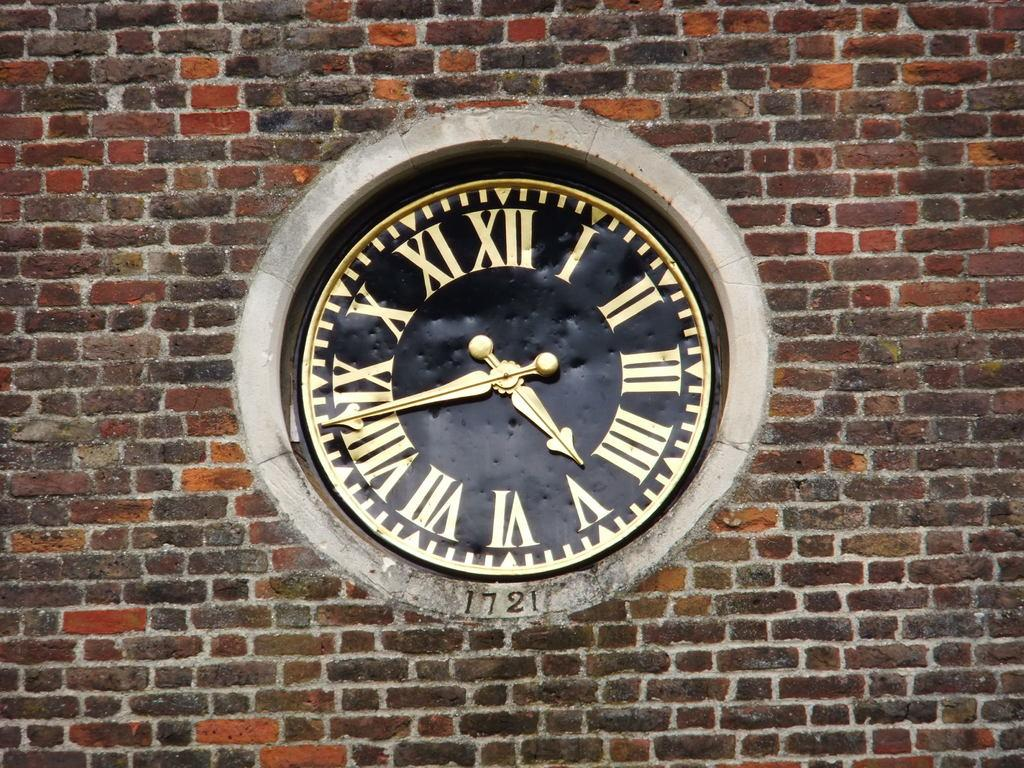<image>
Create a compact narrative representing the image presented. A clock built into a brick wall that says 1721 underneath it. 